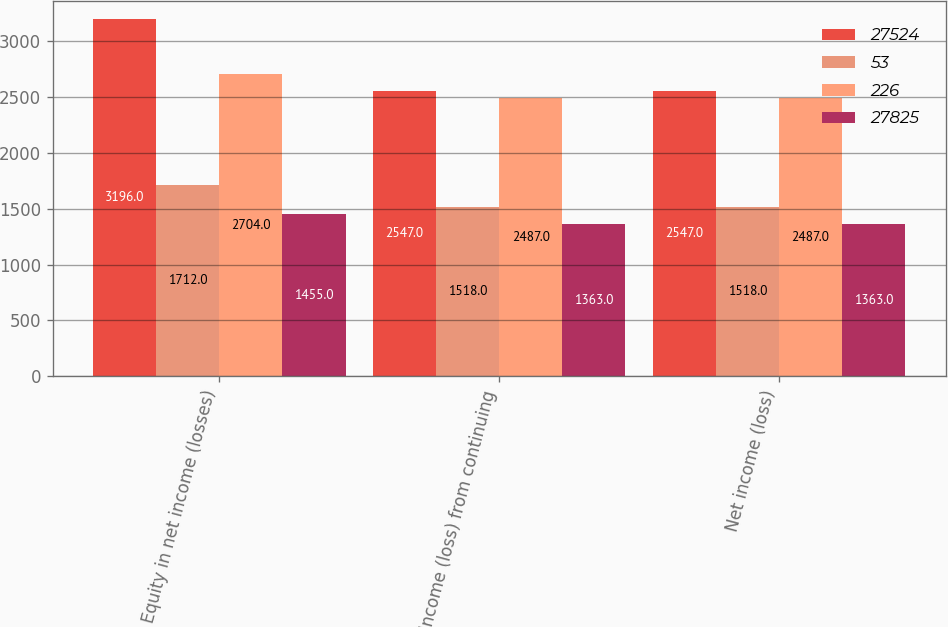<chart> <loc_0><loc_0><loc_500><loc_500><stacked_bar_chart><ecel><fcel>Equity in net income (losses)<fcel>Income (loss) from continuing<fcel>Net income (loss)<nl><fcel>27524<fcel>3196<fcel>2547<fcel>2547<nl><fcel>53<fcel>1712<fcel>1518<fcel>1518<nl><fcel>226<fcel>2704<fcel>2487<fcel>2487<nl><fcel>27825<fcel>1455<fcel>1363<fcel>1363<nl></chart> 